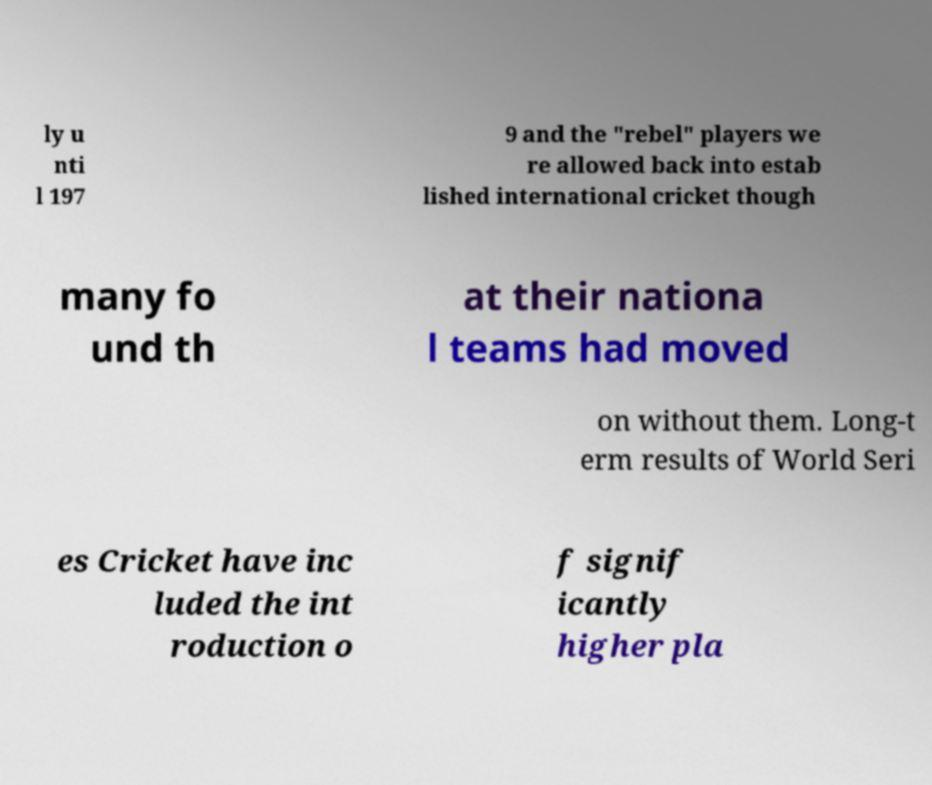For documentation purposes, I need the text within this image transcribed. Could you provide that? ly u nti l 197 9 and the "rebel" players we re allowed back into estab lished international cricket though many fo und th at their nationa l teams had moved on without them. Long-t erm results of World Seri es Cricket have inc luded the int roduction o f signif icantly higher pla 